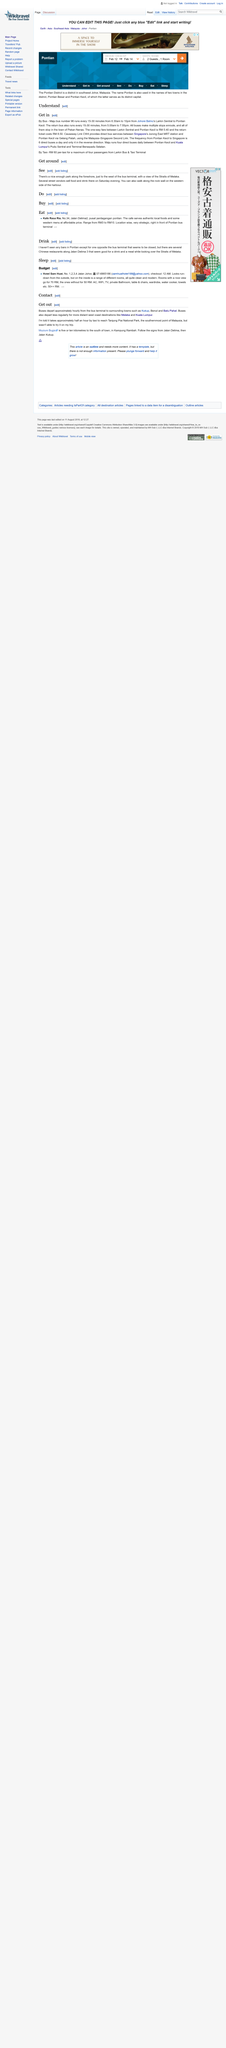Highlight a few significant elements in this photo. There are six direct buses that operate daily between Pontian Kecil and Singapore. Yes, it is possible to get to Pontian Kecil by bus. All buses stop at the town of Pekan Nenas. 